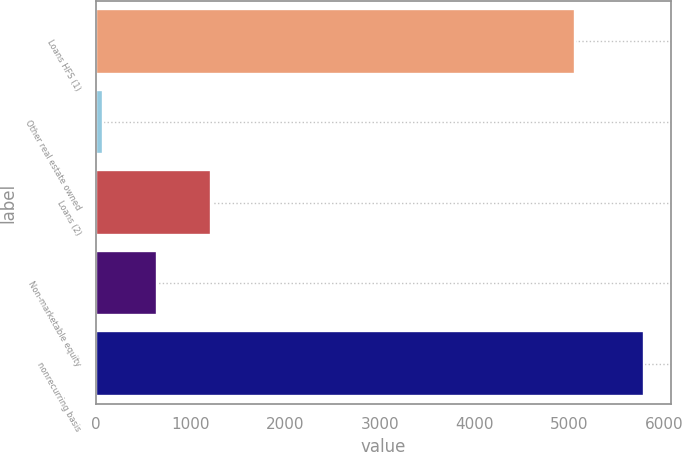Convert chart. <chart><loc_0><loc_0><loc_500><loc_500><bar_chart><fcel>Loans HFS (1)<fcel>Other real estate owned<fcel>Loans (2)<fcel>Non-marketable equity<fcel>nonrecurring basis<nl><fcel>5055<fcel>78<fcel>1219.2<fcel>648.6<fcel>5784<nl></chart> 